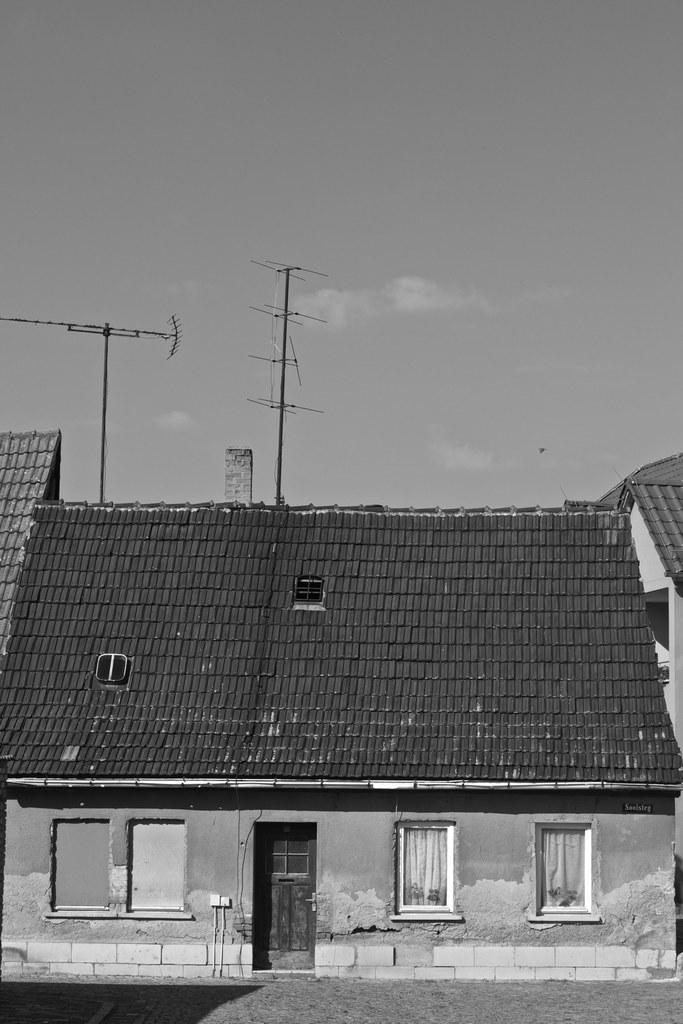What type of structures can be seen in the image? There are houses in the image. What else is present in the image besides the houses? There are poles in the image. How would you describe the sky in the image? The sky is cloudy in the image. Can you see any stars in the image? There are no stars visible in the image, as the sky is cloudy. What type of clothing is worn by the wilderness in the image? There is no wilderness present in the image, and therefore no clothing can be associated with it. 